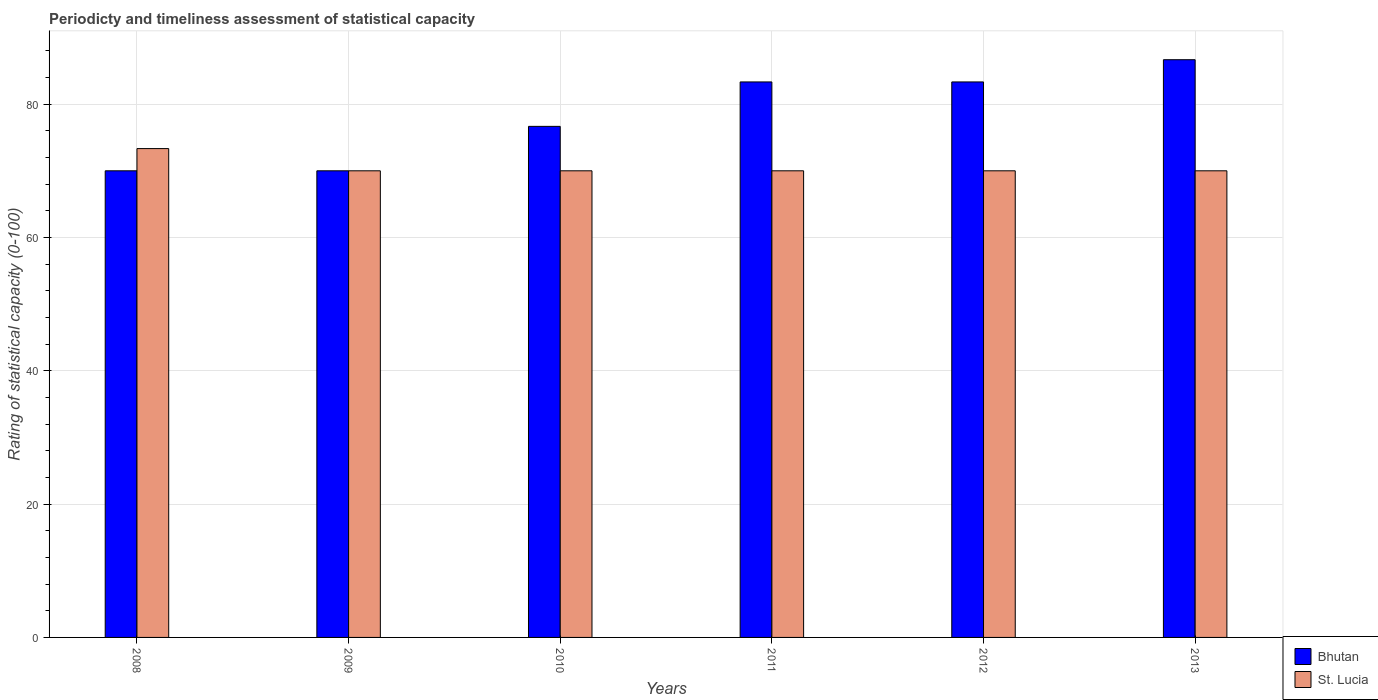How many different coloured bars are there?
Offer a terse response. 2. What is the rating of statistical capacity in Bhutan in 2012?
Give a very brief answer. 83.33. Across all years, what is the maximum rating of statistical capacity in St. Lucia?
Offer a very short reply. 73.33. Across all years, what is the minimum rating of statistical capacity in Bhutan?
Ensure brevity in your answer.  70. What is the total rating of statistical capacity in St. Lucia in the graph?
Keep it short and to the point. 423.33. What is the difference between the rating of statistical capacity in Bhutan in 2009 and that in 2011?
Your answer should be compact. -13.33. What is the difference between the rating of statistical capacity in Bhutan in 2010 and the rating of statistical capacity in St. Lucia in 2009?
Your response must be concise. 6.67. What is the average rating of statistical capacity in Bhutan per year?
Ensure brevity in your answer.  78.33. In the year 2012, what is the difference between the rating of statistical capacity in Bhutan and rating of statistical capacity in St. Lucia?
Provide a short and direct response. 13.33. In how many years, is the rating of statistical capacity in St. Lucia greater than 56?
Provide a short and direct response. 6. What is the ratio of the rating of statistical capacity in St. Lucia in 2008 to that in 2010?
Ensure brevity in your answer.  1.05. Is the difference between the rating of statistical capacity in Bhutan in 2008 and 2010 greater than the difference between the rating of statistical capacity in St. Lucia in 2008 and 2010?
Offer a terse response. No. What is the difference between the highest and the second highest rating of statistical capacity in St. Lucia?
Keep it short and to the point. 3.33. What is the difference between the highest and the lowest rating of statistical capacity in Bhutan?
Ensure brevity in your answer.  16.67. In how many years, is the rating of statistical capacity in St. Lucia greater than the average rating of statistical capacity in St. Lucia taken over all years?
Offer a terse response. 1. Is the sum of the rating of statistical capacity in St. Lucia in 2008 and 2011 greater than the maximum rating of statistical capacity in Bhutan across all years?
Ensure brevity in your answer.  Yes. What does the 1st bar from the left in 2010 represents?
Your answer should be compact. Bhutan. What does the 2nd bar from the right in 2009 represents?
Your response must be concise. Bhutan. How many bars are there?
Ensure brevity in your answer.  12. Are all the bars in the graph horizontal?
Provide a short and direct response. No. How many years are there in the graph?
Your answer should be very brief. 6. What is the title of the graph?
Your response must be concise. Periodicty and timeliness assessment of statistical capacity. What is the label or title of the Y-axis?
Your response must be concise. Rating of statistical capacity (0-100). What is the Rating of statistical capacity (0-100) of Bhutan in 2008?
Keep it short and to the point. 70. What is the Rating of statistical capacity (0-100) of St. Lucia in 2008?
Give a very brief answer. 73.33. What is the Rating of statistical capacity (0-100) of Bhutan in 2009?
Offer a terse response. 70. What is the Rating of statistical capacity (0-100) of Bhutan in 2010?
Ensure brevity in your answer.  76.67. What is the Rating of statistical capacity (0-100) in St. Lucia in 2010?
Offer a terse response. 70. What is the Rating of statistical capacity (0-100) of Bhutan in 2011?
Offer a very short reply. 83.33. What is the Rating of statistical capacity (0-100) of St. Lucia in 2011?
Offer a very short reply. 70. What is the Rating of statistical capacity (0-100) of Bhutan in 2012?
Ensure brevity in your answer.  83.33. What is the Rating of statistical capacity (0-100) in St. Lucia in 2012?
Offer a very short reply. 70. What is the Rating of statistical capacity (0-100) in Bhutan in 2013?
Provide a short and direct response. 86.67. What is the Rating of statistical capacity (0-100) of St. Lucia in 2013?
Offer a very short reply. 70. Across all years, what is the maximum Rating of statistical capacity (0-100) of Bhutan?
Ensure brevity in your answer.  86.67. Across all years, what is the maximum Rating of statistical capacity (0-100) in St. Lucia?
Give a very brief answer. 73.33. Across all years, what is the minimum Rating of statistical capacity (0-100) of Bhutan?
Ensure brevity in your answer.  70. Across all years, what is the minimum Rating of statistical capacity (0-100) of St. Lucia?
Offer a terse response. 70. What is the total Rating of statistical capacity (0-100) of Bhutan in the graph?
Make the answer very short. 470. What is the total Rating of statistical capacity (0-100) in St. Lucia in the graph?
Offer a terse response. 423.33. What is the difference between the Rating of statistical capacity (0-100) of Bhutan in 2008 and that in 2009?
Offer a terse response. 0. What is the difference between the Rating of statistical capacity (0-100) of St. Lucia in 2008 and that in 2009?
Your answer should be compact. 3.33. What is the difference between the Rating of statistical capacity (0-100) of Bhutan in 2008 and that in 2010?
Keep it short and to the point. -6.67. What is the difference between the Rating of statistical capacity (0-100) of Bhutan in 2008 and that in 2011?
Ensure brevity in your answer.  -13.33. What is the difference between the Rating of statistical capacity (0-100) in St. Lucia in 2008 and that in 2011?
Your answer should be very brief. 3.33. What is the difference between the Rating of statistical capacity (0-100) in Bhutan in 2008 and that in 2012?
Keep it short and to the point. -13.33. What is the difference between the Rating of statistical capacity (0-100) in St. Lucia in 2008 and that in 2012?
Provide a succinct answer. 3.33. What is the difference between the Rating of statistical capacity (0-100) of Bhutan in 2008 and that in 2013?
Offer a very short reply. -16.67. What is the difference between the Rating of statistical capacity (0-100) in Bhutan in 2009 and that in 2010?
Ensure brevity in your answer.  -6.67. What is the difference between the Rating of statistical capacity (0-100) in St. Lucia in 2009 and that in 2010?
Offer a very short reply. 0. What is the difference between the Rating of statistical capacity (0-100) of Bhutan in 2009 and that in 2011?
Ensure brevity in your answer.  -13.33. What is the difference between the Rating of statistical capacity (0-100) of St. Lucia in 2009 and that in 2011?
Give a very brief answer. 0. What is the difference between the Rating of statistical capacity (0-100) in Bhutan in 2009 and that in 2012?
Ensure brevity in your answer.  -13.33. What is the difference between the Rating of statistical capacity (0-100) in St. Lucia in 2009 and that in 2012?
Provide a succinct answer. 0. What is the difference between the Rating of statistical capacity (0-100) in Bhutan in 2009 and that in 2013?
Your answer should be very brief. -16.67. What is the difference between the Rating of statistical capacity (0-100) of St. Lucia in 2009 and that in 2013?
Make the answer very short. 0. What is the difference between the Rating of statistical capacity (0-100) in Bhutan in 2010 and that in 2011?
Provide a succinct answer. -6.67. What is the difference between the Rating of statistical capacity (0-100) of Bhutan in 2010 and that in 2012?
Provide a succinct answer. -6.67. What is the difference between the Rating of statistical capacity (0-100) of St. Lucia in 2010 and that in 2012?
Provide a succinct answer. 0. What is the difference between the Rating of statistical capacity (0-100) of St. Lucia in 2010 and that in 2013?
Keep it short and to the point. 0. What is the difference between the Rating of statistical capacity (0-100) in Bhutan in 2011 and that in 2012?
Offer a terse response. 0. What is the difference between the Rating of statistical capacity (0-100) in St. Lucia in 2011 and that in 2012?
Your answer should be compact. 0. What is the difference between the Rating of statistical capacity (0-100) in Bhutan in 2012 and that in 2013?
Make the answer very short. -3.33. What is the difference between the Rating of statistical capacity (0-100) in St. Lucia in 2012 and that in 2013?
Provide a succinct answer. 0. What is the difference between the Rating of statistical capacity (0-100) of Bhutan in 2008 and the Rating of statistical capacity (0-100) of St. Lucia in 2009?
Give a very brief answer. 0. What is the difference between the Rating of statistical capacity (0-100) in Bhutan in 2008 and the Rating of statistical capacity (0-100) in St. Lucia in 2013?
Give a very brief answer. 0. What is the difference between the Rating of statistical capacity (0-100) in Bhutan in 2009 and the Rating of statistical capacity (0-100) in St. Lucia in 2010?
Keep it short and to the point. 0. What is the difference between the Rating of statistical capacity (0-100) in Bhutan in 2009 and the Rating of statistical capacity (0-100) in St. Lucia in 2013?
Offer a terse response. 0. What is the difference between the Rating of statistical capacity (0-100) of Bhutan in 2010 and the Rating of statistical capacity (0-100) of St. Lucia in 2013?
Your response must be concise. 6.67. What is the difference between the Rating of statistical capacity (0-100) in Bhutan in 2011 and the Rating of statistical capacity (0-100) in St. Lucia in 2012?
Provide a short and direct response. 13.33. What is the difference between the Rating of statistical capacity (0-100) in Bhutan in 2011 and the Rating of statistical capacity (0-100) in St. Lucia in 2013?
Provide a short and direct response. 13.33. What is the difference between the Rating of statistical capacity (0-100) of Bhutan in 2012 and the Rating of statistical capacity (0-100) of St. Lucia in 2013?
Give a very brief answer. 13.33. What is the average Rating of statistical capacity (0-100) in Bhutan per year?
Your answer should be very brief. 78.33. What is the average Rating of statistical capacity (0-100) of St. Lucia per year?
Your answer should be very brief. 70.56. In the year 2010, what is the difference between the Rating of statistical capacity (0-100) in Bhutan and Rating of statistical capacity (0-100) in St. Lucia?
Offer a very short reply. 6.67. In the year 2011, what is the difference between the Rating of statistical capacity (0-100) of Bhutan and Rating of statistical capacity (0-100) of St. Lucia?
Give a very brief answer. 13.33. In the year 2012, what is the difference between the Rating of statistical capacity (0-100) of Bhutan and Rating of statistical capacity (0-100) of St. Lucia?
Your answer should be very brief. 13.33. In the year 2013, what is the difference between the Rating of statistical capacity (0-100) in Bhutan and Rating of statistical capacity (0-100) in St. Lucia?
Ensure brevity in your answer.  16.67. What is the ratio of the Rating of statistical capacity (0-100) in Bhutan in 2008 to that in 2009?
Provide a short and direct response. 1. What is the ratio of the Rating of statistical capacity (0-100) in St. Lucia in 2008 to that in 2009?
Your response must be concise. 1.05. What is the ratio of the Rating of statistical capacity (0-100) in St. Lucia in 2008 to that in 2010?
Ensure brevity in your answer.  1.05. What is the ratio of the Rating of statistical capacity (0-100) of Bhutan in 2008 to that in 2011?
Offer a terse response. 0.84. What is the ratio of the Rating of statistical capacity (0-100) of St. Lucia in 2008 to that in 2011?
Your response must be concise. 1.05. What is the ratio of the Rating of statistical capacity (0-100) in Bhutan in 2008 to that in 2012?
Provide a succinct answer. 0.84. What is the ratio of the Rating of statistical capacity (0-100) of St. Lucia in 2008 to that in 2012?
Make the answer very short. 1.05. What is the ratio of the Rating of statistical capacity (0-100) in Bhutan in 2008 to that in 2013?
Make the answer very short. 0.81. What is the ratio of the Rating of statistical capacity (0-100) in St. Lucia in 2008 to that in 2013?
Your response must be concise. 1.05. What is the ratio of the Rating of statistical capacity (0-100) in Bhutan in 2009 to that in 2011?
Give a very brief answer. 0.84. What is the ratio of the Rating of statistical capacity (0-100) in Bhutan in 2009 to that in 2012?
Make the answer very short. 0.84. What is the ratio of the Rating of statistical capacity (0-100) of Bhutan in 2009 to that in 2013?
Provide a short and direct response. 0.81. What is the ratio of the Rating of statistical capacity (0-100) in St. Lucia in 2010 to that in 2012?
Your answer should be compact. 1. What is the ratio of the Rating of statistical capacity (0-100) of Bhutan in 2010 to that in 2013?
Make the answer very short. 0.88. What is the ratio of the Rating of statistical capacity (0-100) of St. Lucia in 2011 to that in 2012?
Your answer should be compact. 1. What is the ratio of the Rating of statistical capacity (0-100) in Bhutan in 2011 to that in 2013?
Your response must be concise. 0.96. What is the ratio of the Rating of statistical capacity (0-100) of Bhutan in 2012 to that in 2013?
Give a very brief answer. 0.96. What is the ratio of the Rating of statistical capacity (0-100) of St. Lucia in 2012 to that in 2013?
Give a very brief answer. 1. What is the difference between the highest and the second highest Rating of statistical capacity (0-100) of Bhutan?
Offer a terse response. 3.33. What is the difference between the highest and the second highest Rating of statistical capacity (0-100) of St. Lucia?
Your response must be concise. 3.33. What is the difference between the highest and the lowest Rating of statistical capacity (0-100) in Bhutan?
Offer a terse response. 16.67. What is the difference between the highest and the lowest Rating of statistical capacity (0-100) of St. Lucia?
Keep it short and to the point. 3.33. 